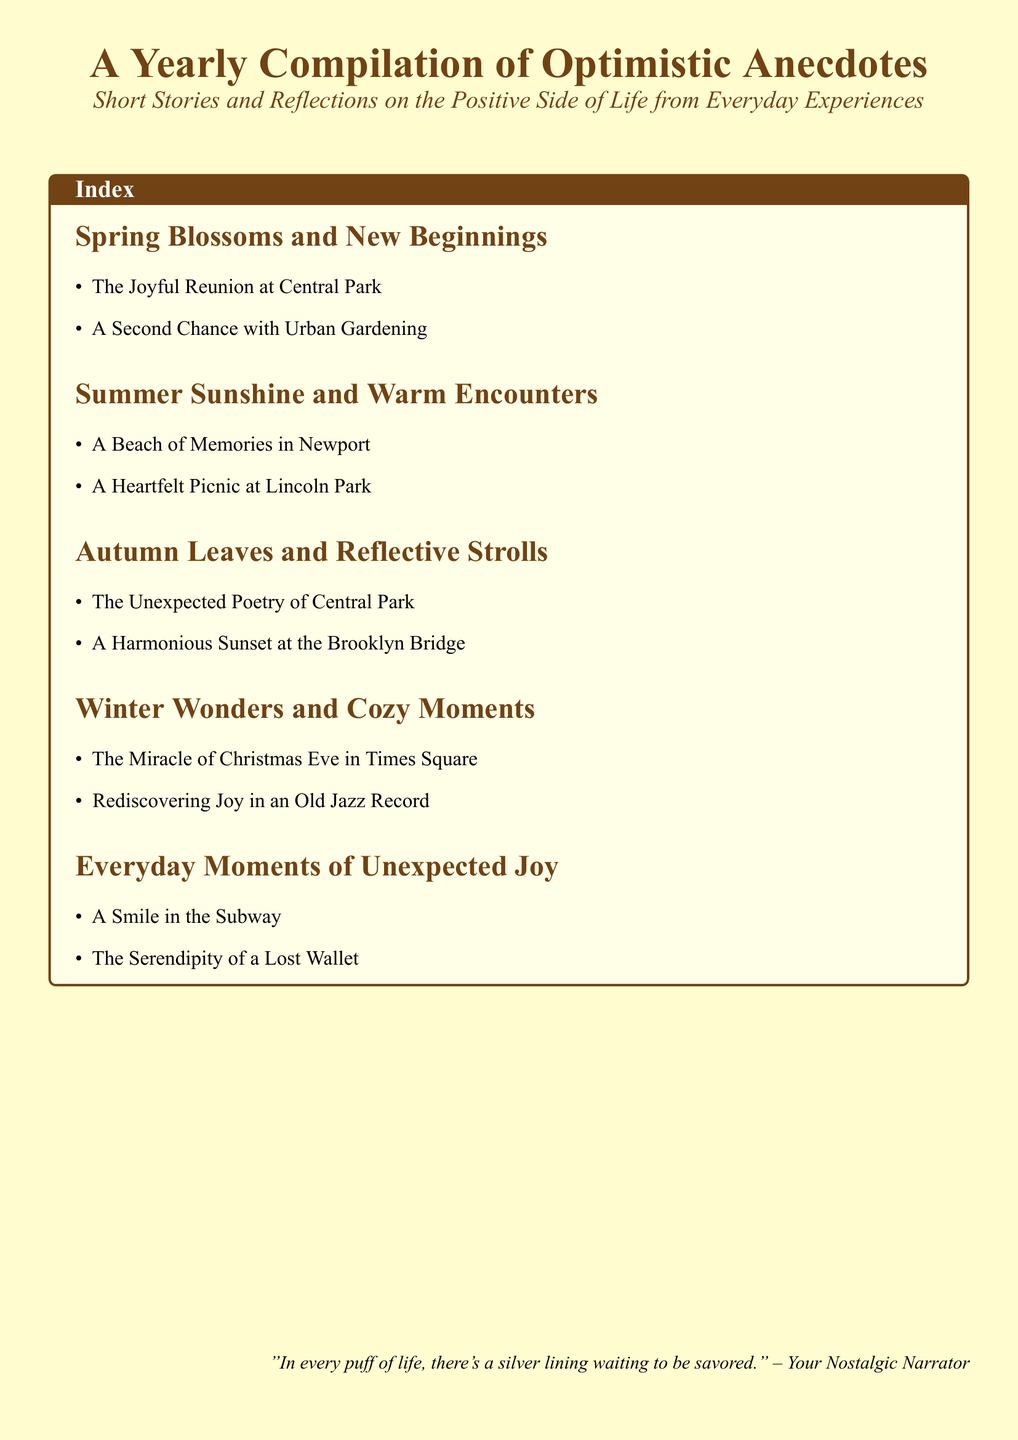What is the title of the document? The title of the document is indicated prominently at the top of the page.
Answer: A Yearly Compilation of Optimistic Anecdotes How many sections are in the document? The document includes five distinct sections addressing different themes.
Answer: 5 What is one story listed under 'Spring Blossoms and New Beginnings'? Each section features specific stories, with the first section including two named anecdotes.
Answer: The Joyful Reunion at Central Park Which season is associated with the story 'A Harmonious Sunset at the Brooklyn Bridge'? Stories are categorized by season, so this question looks for the correct grouping.
Answer: Autumn What kind of experience is highlighted in 'Everyday Moments of Unexpected Joy'? This subsection captures a specific type of experience from daily life themes.
Answer: Unexpected Joy What is the color theme of the document's background? The color choices are described at the start, indicating the intentional use of color.
Answer: Cream How many stories are listed under 'Winter Wonders and Cozy Moments'? Each section has a specific number of stories, which can be counted.
Answer: 2 What is the quote seen at the bottom of the page? The document wraps up with a reflective quote that encapsulates its essence.
Answer: In every puff of life, there's a silver lining waiting to be savored 